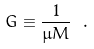<formula> <loc_0><loc_0><loc_500><loc_500>G \equiv \frac { 1 } { \mu M } \ .</formula> 